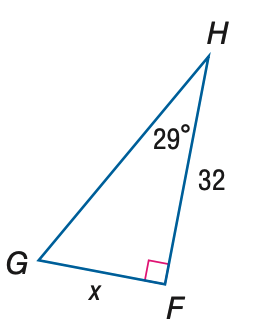Question: Find x. Round to the nearest tenth.
Choices:
A. 17.7
B. 36.6
C. 57.7
D. 66.0
Answer with the letter. Answer: A 